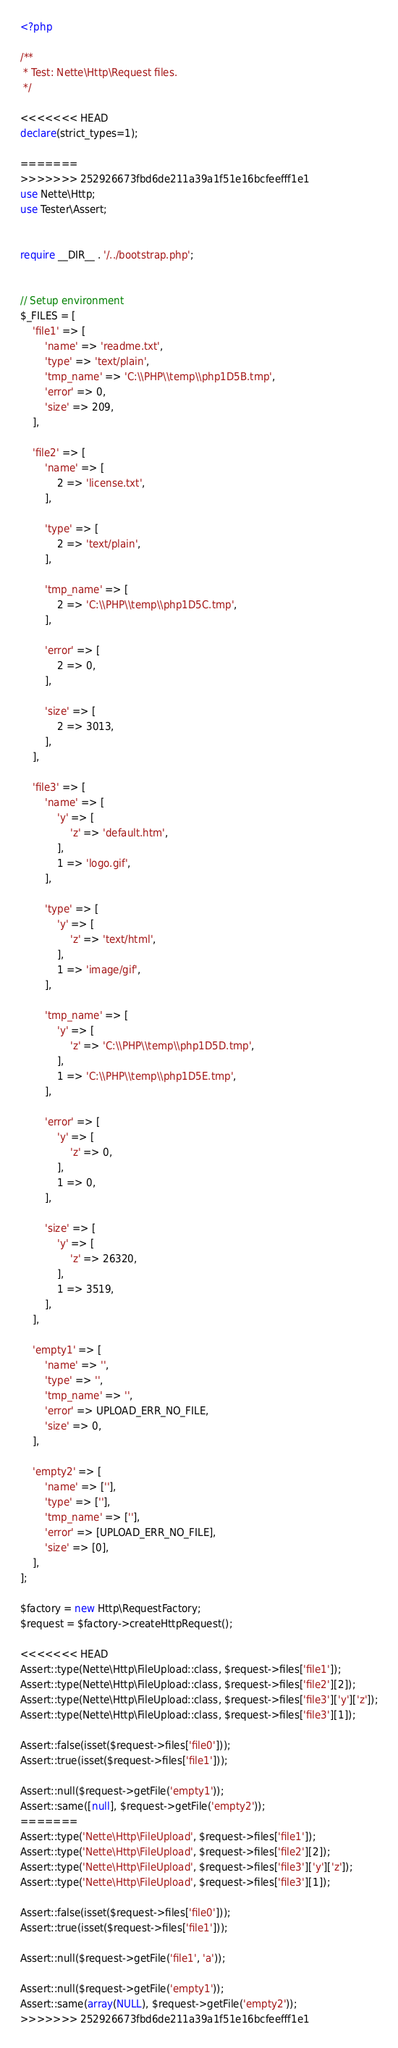Convert code to text. <code><loc_0><loc_0><loc_500><loc_500><_PHP_><?php

/**
 * Test: Nette\Http\Request files.
 */

<<<<<<< HEAD
declare(strict_types=1);

=======
>>>>>>> 252926673fbd6de211a39a1f51e16bcfeefff1e1
use Nette\Http;
use Tester\Assert;


require __DIR__ . '/../bootstrap.php';


// Setup environment
$_FILES = [
	'file1' => [
		'name' => 'readme.txt',
		'type' => 'text/plain',
		'tmp_name' => 'C:\\PHP\\temp\\php1D5B.tmp',
		'error' => 0,
		'size' => 209,
	],

	'file2' => [
		'name' => [
			2 => 'license.txt',
		],

		'type' => [
			2 => 'text/plain',
		],

		'tmp_name' => [
			2 => 'C:\\PHP\\temp\\php1D5C.tmp',
		],

		'error' => [
			2 => 0,
		],

		'size' => [
			2 => 3013,
		],
	],

	'file3' => [
		'name' => [
			'y' => [
				'z' => 'default.htm',
			],
			1 => 'logo.gif',
		],

		'type' => [
			'y' => [
				'z' => 'text/html',
			],
			1 => 'image/gif',
		],

		'tmp_name' => [
			'y' => [
				'z' => 'C:\\PHP\\temp\\php1D5D.tmp',
			],
			1 => 'C:\\PHP\\temp\\php1D5E.tmp',
		],

		'error' => [
			'y' => [
				'z' => 0,
			],
			1 => 0,
		],

		'size' => [
			'y' => [
				'z' => 26320,
			],
			1 => 3519,
		],
	],

	'empty1' => [
		'name' => '',
		'type' => '',
		'tmp_name' => '',
		'error' => UPLOAD_ERR_NO_FILE,
		'size' => 0,
	],

	'empty2' => [
		'name' => [''],
		'type' => [''],
		'tmp_name' => [''],
		'error' => [UPLOAD_ERR_NO_FILE],
		'size' => [0],
	],
];

$factory = new Http\RequestFactory;
$request = $factory->createHttpRequest();

<<<<<<< HEAD
Assert::type(Nette\Http\FileUpload::class, $request->files['file1']);
Assert::type(Nette\Http\FileUpload::class, $request->files['file2'][2]);
Assert::type(Nette\Http\FileUpload::class, $request->files['file3']['y']['z']);
Assert::type(Nette\Http\FileUpload::class, $request->files['file3'][1]);

Assert::false(isset($request->files['file0']));
Assert::true(isset($request->files['file1']));

Assert::null($request->getFile('empty1'));
Assert::same([null], $request->getFile('empty2'));
=======
Assert::type('Nette\Http\FileUpload', $request->files['file1']);
Assert::type('Nette\Http\FileUpload', $request->files['file2'][2]);
Assert::type('Nette\Http\FileUpload', $request->files['file3']['y']['z']);
Assert::type('Nette\Http\FileUpload', $request->files['file3'][1]);

Assert::false(isset($request->files['file0']));
Assert::true(isset($request->files['file1']));

Assert::null($request->getFile('file1', 'a'));

Assert::null($request->getFile('empty1'));
Assert::same(array(NULL), $request->getFile('empty2'));
>>>>>>> 252926673fbd6de211a39a1f51e16bcfeefff1e1
</code> 